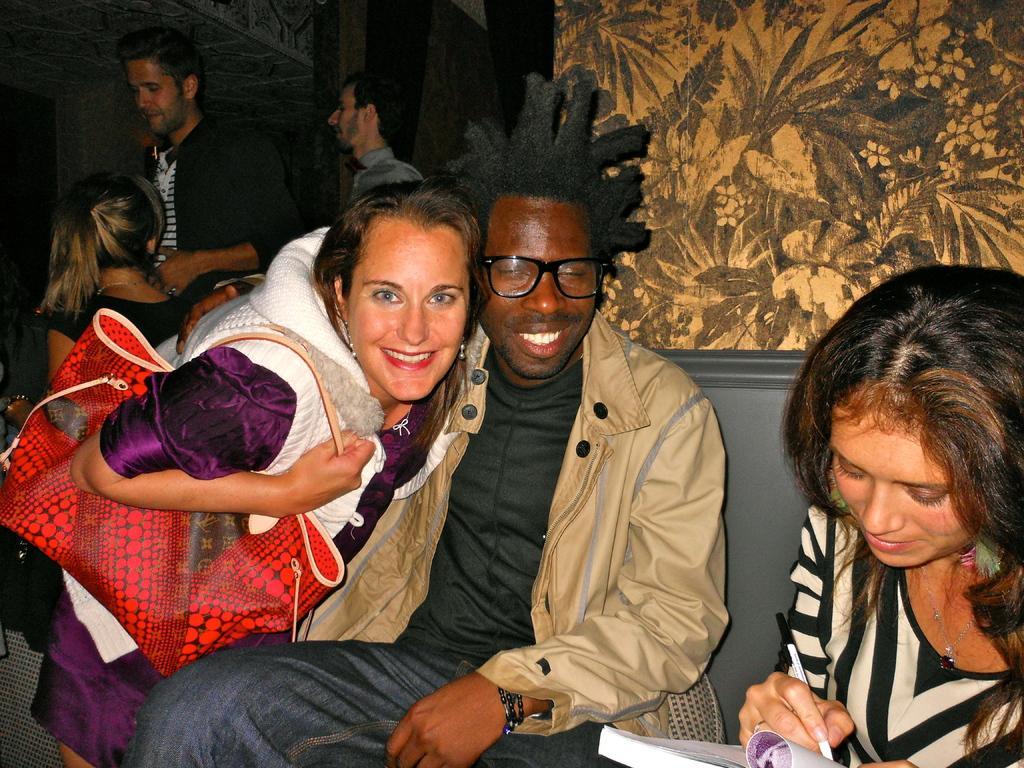Please provide a concise description of this image. In this image we can see few people. Some are sitting and some are standing. Person on the right side is holding a book and writing with a pen. Another person is wearing specs. Another lady is wearing a bag. In the back there is a wall. 